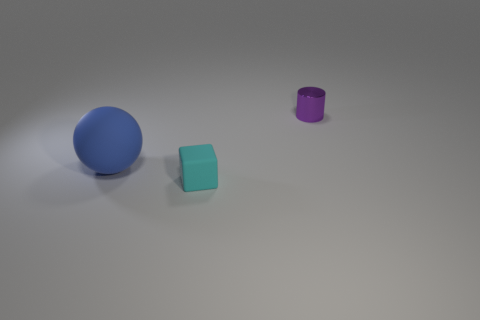How many blue matte objects are in front of the tiny thing in front of the small purple metallic cylinder? 0 